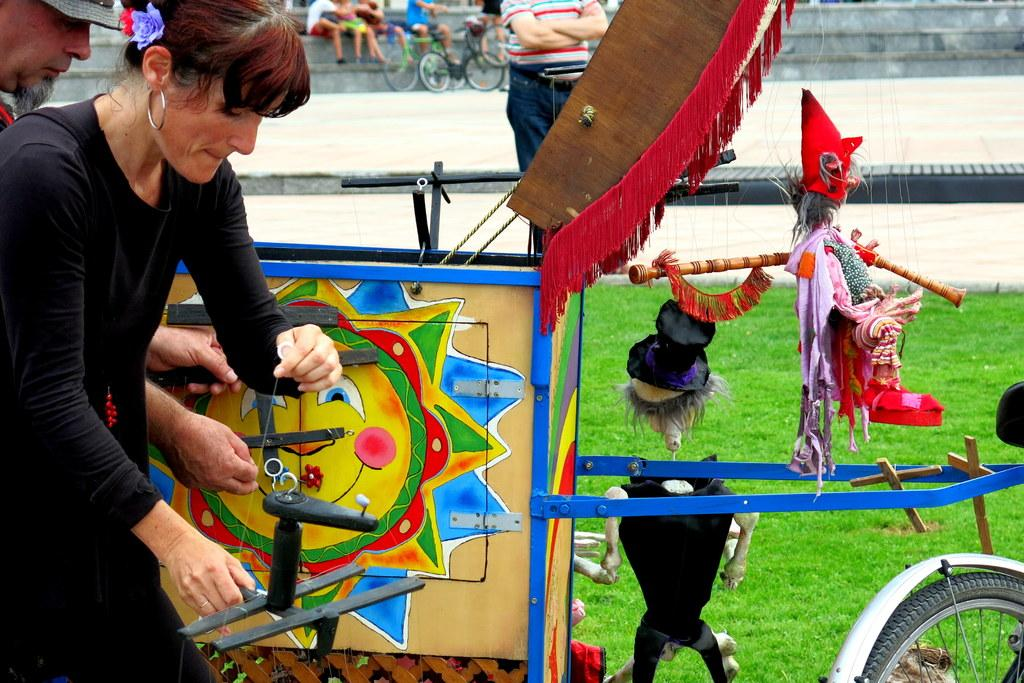What is the main object in the image? There is a painting board in the image. What can be seen besides the painting board? There are bicycles, a path, stairs, grass, people, and other objects in the image. Can you describe the setting of the image? The image features a painting board, bicycles, a path, stairs, grass, and people, suggesting an outdoor or recreational area. How many babies are present in the image? There is no mention of babies in the image; the facts provided do not mention any infants. 